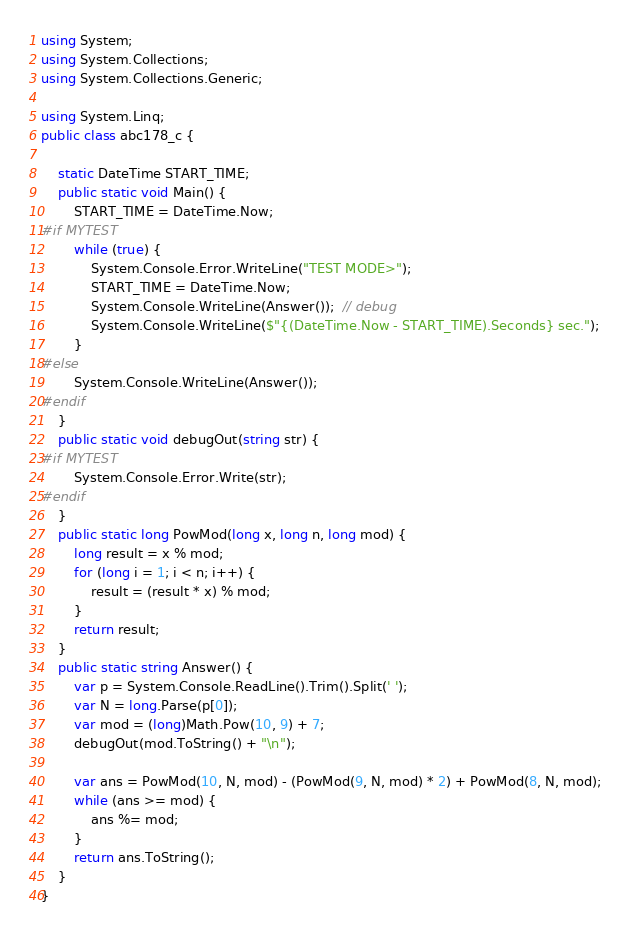Convert code to text. <code><loc_0><loc_0><loc_500><loc_500><_C#_>using System;
using System.Collections;
using System.Collections.Generic;

using System.Linq;
public class abc178_c {

    static DateTime START_TIME;
    public static void Main() {
        START_TIME = DateTime.Now;
#if MYTEST
        while (true) {
            System.Console.Error.WriteLine("TEST MODE>");
            START_TIME = DateTime.Now;
            System.Console.WriteLine(Answer());  // debug
            System.Console.WriteLine($"{(DateTime.Now - START_TIME).Seconds} sec.");
        }
#else
        System.Console.WriteLine(Answer());
#endif
    }
    public static void debugOut(string str) {
#if MYTEST
        System.Console.Error.Write(str);
#endif
    }
    public static long PowMod(long x, long n, long mod) {
        long result = x % mod;
        for (long i = 1; i < n; i++) {
            result = (result * x) % mod;
        }
        return result;
    }
    public static string Answer() {
        var p = System.Console.ReadLine().Trim().Split(' ');
        var N = long.Parse(p[0]);
        var mod = (long)Math.Pow(10, 9) + 7;
        debugOut(mod.ToString() + "\n");

        var ans = PowMod(10, N, mod) - (PowMod(9, N, mod) * 2) + PowMod(8, N, mod);
        while (ans >= mod) {
            ans %= mod;
        }
        return ans.ToString();
    }
}
</code> 